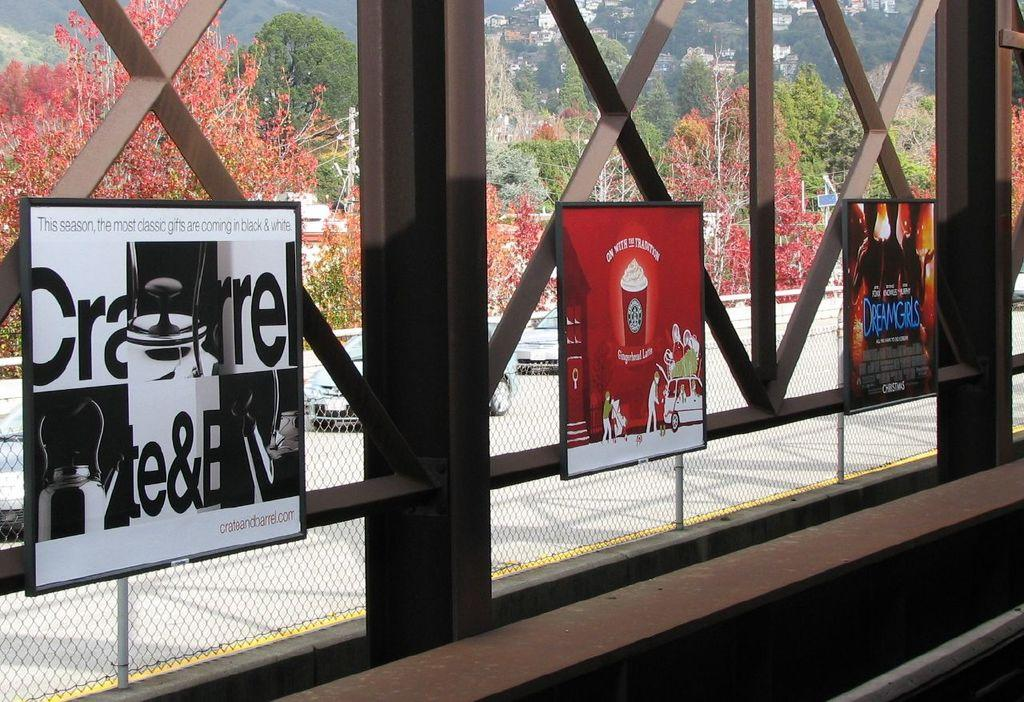What type of structures can be seen in the image? There are boards, a fence, metal rods, trees, mountains, and houses visible in the image. What is the weather like in the image? The image was likely taken during a sunny day. What type of pet can be seen playing with a zinc object in the image? There is no pet or zinc object present in the image. Is the queen visible in the image? There is no queen present in the image. 